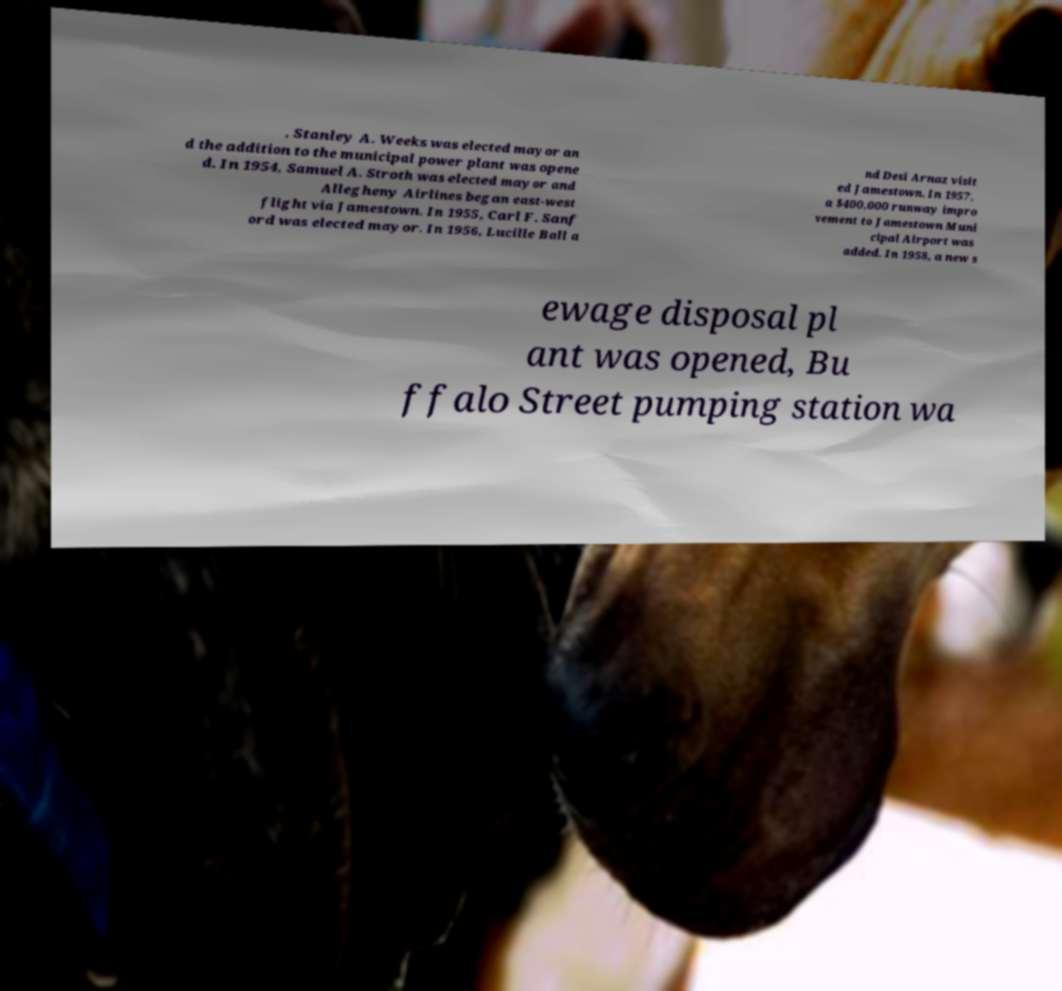Could you assist in decoding the text presented in this image and type it out clearly? , Stanley A. Weeks was elected mayor an d the addition to the municipal power plant was opene d. In 1954, Samuel A. Stroth was elected mayor and Allegheny Airlines began east-west flight via Jamestown. In 1955, Carl F. Sanf ord was elected mayor. In 1956, Lucille Ball a nd Desi Arnaz visit ed Jamestown. In 1957, a $400,000 runway impro vement to Jamestown Muni cipal Airport was added. In 1958, a new s ewage disposal pl ant was opened, Bu ffalo Street pumping station wa 